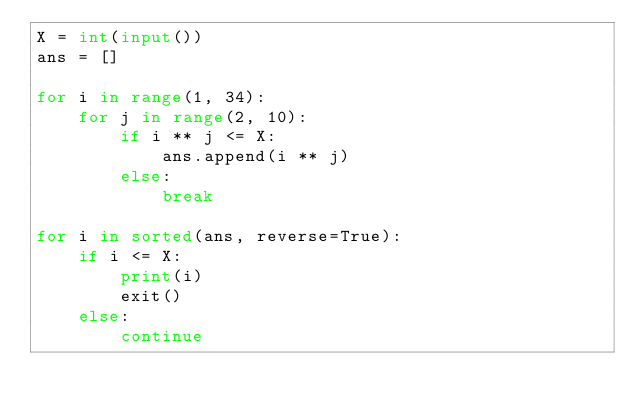<code> <loc_0><loc_0><loc_500><loc_500><_Python_>X = int(input())
ans = []

for i in range(1, 34):
    for j in range(2, 10):
        if i ** j <= X:
            ans.append(i ** j)
        else:
            break

for i in sorted(ans, reverse=True):
    if i <= X:
        print(i)
        exit()
    else:
        continue</code> 